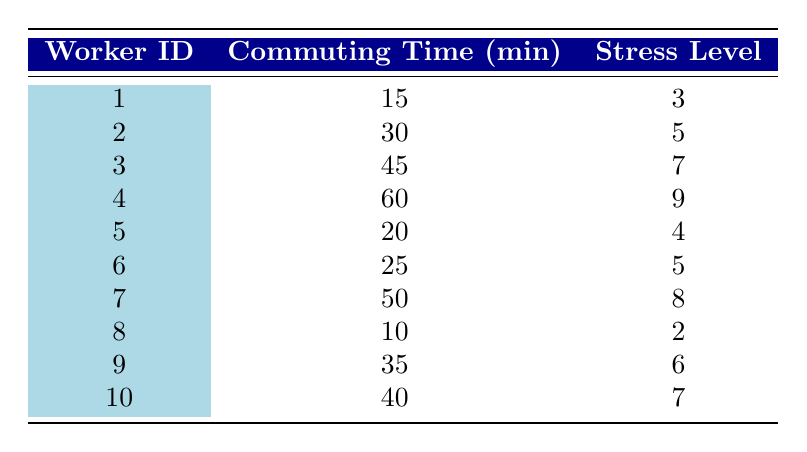What is the stress level for worker ID 4? By looking at the table, we can find the row corresponding to worker ID 4, which shows a stress level of 9.
Answer: 9 What is the commuting time for worker ID 7? Examining the table, we see that the commuting time for worker ID 7 is listed as 50 minutes.
Answer: 50 Which worker has the highest stress level, and what is that level? The maximum stress level in the table is found by scanning through the stress level column, where worker ID 4 has the highest stress level of 9.
Answer: Worker ID 4; 9 What is the average commuting time for all the workers? To find the average commuting time, we add all commuting times: (15 + 30 + 45 + 60 + 20 + 25 + 50 + 10 + 35 + 40) = 350 minutes. There are 10 workers, so the average is 350/10 = 35 minutes.
Answer: 35 Is there a worker with a commuting time of 10 minutes? By checking the commuting times in the table, we see that worker ID 8 has a commuting time of 10 minutes. Therefore, the answer is yes.
Answer: Yes What is the difference in stress level between the worker with the shortest and longest commuting time? The shortest commuting time is worker ID 8 with a stress level of 2, and the longest is worker ID 4 with a stress level of 9. The difference is 9 - 2 = 7.
Answer: 7 How many workers have a stress level greater than 6? We check the stress levels in the table and find the following workers with stress levels greater than 6: Worker ID 3 (7), Worker ID 4 (9), and Worker ID 7 (8). This totals to 3 workers.
Answer: 3 What is the total commuting time for workers with stress levels below 5? We look for workers with stress levels less than 5 in the table. Worker ID 1 (3, 15 minutes) and Worker ID 8 (2, 10 minutes) fit this criterion. The total is 15 + 10 = 25 minutes.
Answer: 25 Which worker has a stress level that is equal to their commuting time (in minutes)? We examine each worker's stress level and commuting time: Worker ID 4 has a stress level of 9 and a commuting time of 60 minutes; no worker matches exactly. Thus, the answer is no.
Answer: No 